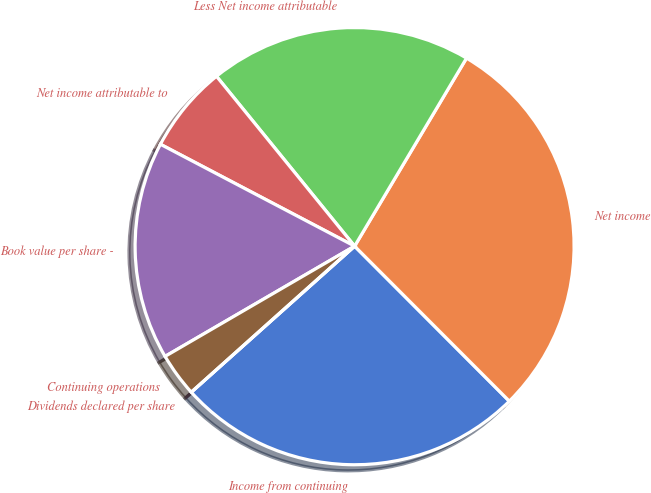Convert chart to OTSL. <chart><loc_0><loc_0><loc_500><loc_500><pie_chart><fcel>Income from continuing<fcel>Net income<fcel>Less Net income attributable<fcel>Net income attributable to<fcel>Book value per share -<fcel>Continuing operations<fcel>Dividends declared per share<nl><fcel>25.81%<fcel>29.03%<fcel>19.35%<fcel>6.45%<fcel>16.13%<fcel>3.23%<fcel>0.0%<nl></chart> 